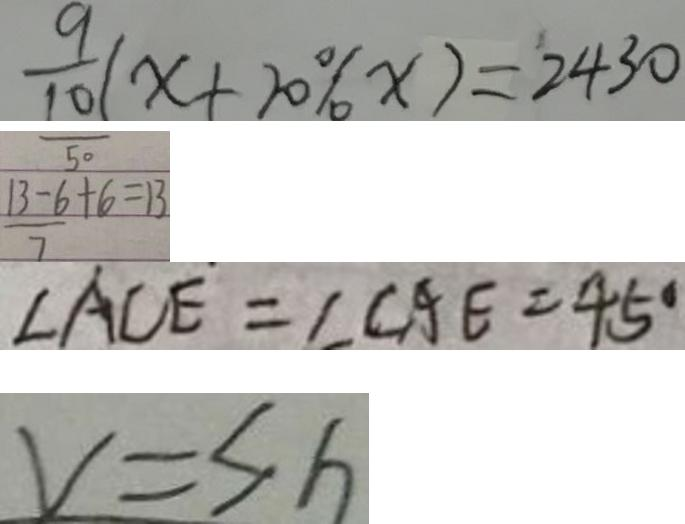Convert formula to latex. <formula><loc_0><loc_0><loc_500><loc_500>\frac { 9 } { 1 0 } ( x + 2 0 \% x ) = 2 4 3 0 
 \frac { 1 3 - 6 } { 7 } + 6 = 1 3 
 \angle A C E = \angle C A E = 4 5 ^ { \circ } 
 V = s h</formula> 